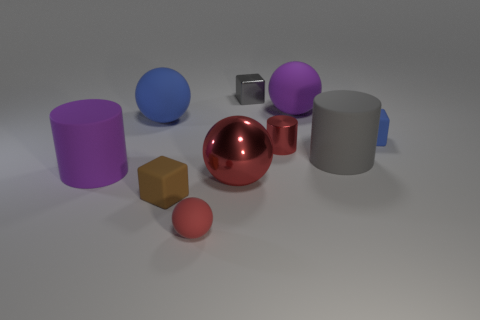Subtract all rubber balls. How many balls are left? 1 Subtract all red cylinders. How many cylinders are left? 2 Subtract 1 red balls. How many objects are left? 9 Subtract all cubes. How many objects are left? 7 Subtract 2 balls. How many balls are left? 2 Subtract all cyan blocks. Subtract all purple cylinders. How many blocks are left? 3 Subtract all red cylinders. How many red spheres are left? 2 Subtract all cyan rubber objects. Subtract all tiny gray shiny blocks. How many objects are left? 9 Add 5 small gray cubes. How many small gray cubes are left? 6 Add 2 gray rubber things. How many gray rubber things exist? 3 